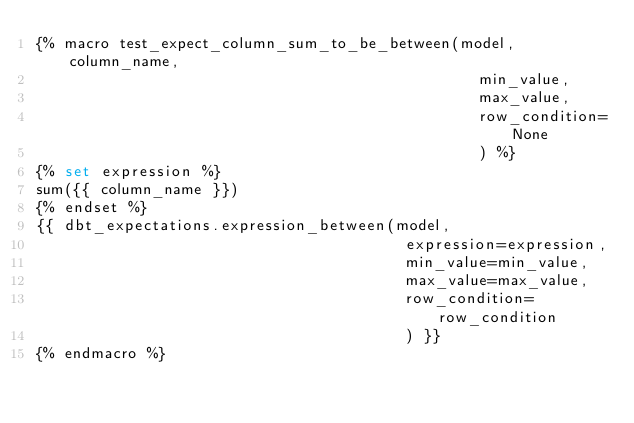Convert code to text. <code><loc_0><loc_0><loc_500><loc_500><_SQL_>{% macro test_expect_column_sum_to_be_between(model, column_name,
                                                min_value,
                                                max_value,
                                                row_condition=None
                                                ) %}
{% set expression %}
sum({{ column_name }})
{% endset %}
{{ dbt_expectations.expression_between(model,
                                        expression=expression,
                                        min_value=min_value,
                                        max_value=max_value,
                                        row_condition=row_condition
                                        ) }}
{% endmacro %}
</code> 